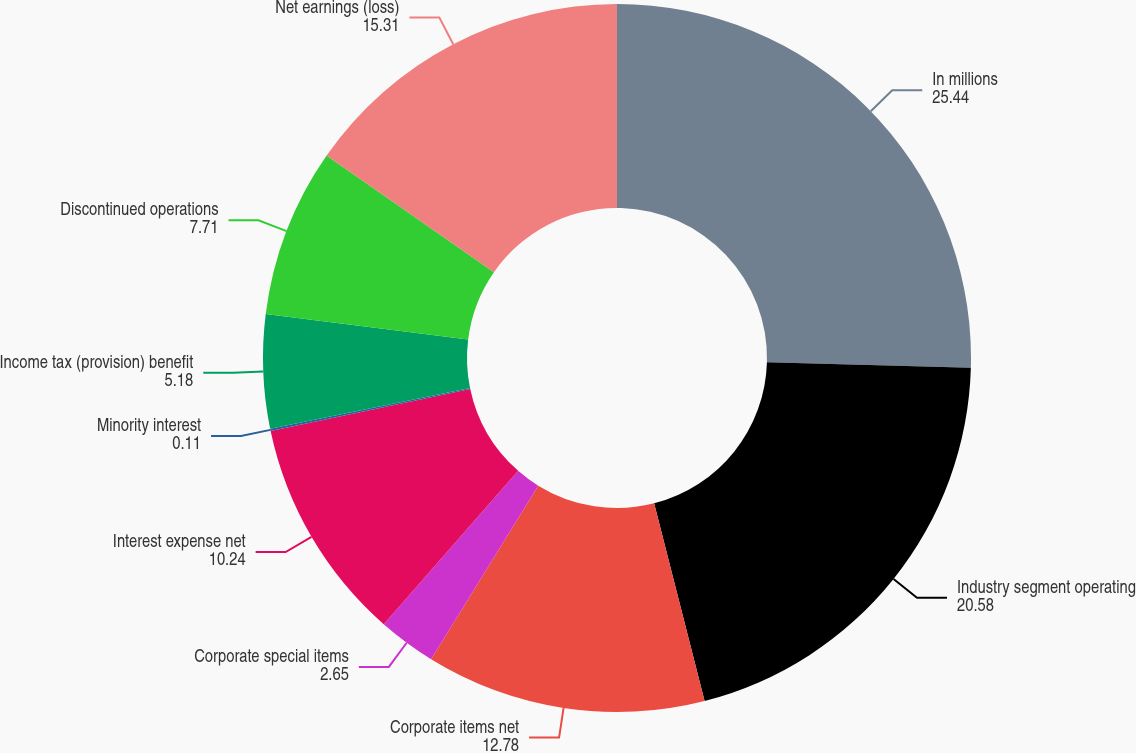Convert chart. <chart><loc_0><loc_0><loc_500><loc_500><pie_chart><fcel>In millions<fcel>Industry segment operating<fcel>Corporate items net<fcel>Corporate special items<fcel>Interest expense net<fcel>Minority interest<fcel>Income tax (provision) benefit<fcel>Discontinued operations<fcel>Net earnings (loss)<nl><fcel>25.44%<fcel>20.58%<fcel>12.78%<fcel>2.65%<fcel>10.24%<fcel>0.11%<fcel>5.18%<fcel>7.71%<fcel>15.31%<nl></chart> 